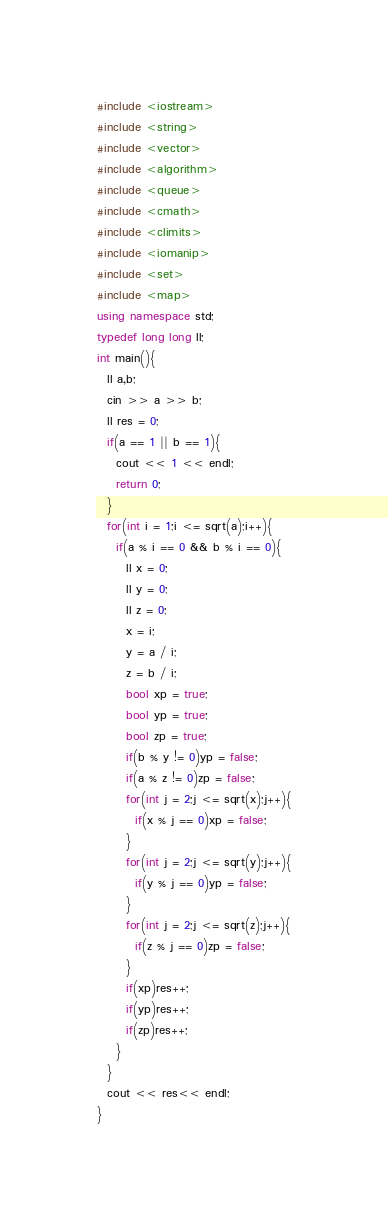Convert code to text. <code><loc_0><loc_0><loc_500><loc_500><_C++_>#include <iostream>
#include <string>
#include <vector>
#include <algorithm>
#include <queue>
#include <cmath>
#include <climits>
#include <iomanip>
#include <set>
#include <map>
using namespace std;
typedef long long ll;
int main(){
  ll a,b;
  cin >> a >> b;
  ll res = 0;
  if(a == 1 || b == 1){
    cout << 1 << endl;
    return 0;
  }
  for(int i = 1;i <= sqrt(a);i++){
    if(a % i == 0 && b % i == 0){
      ll x = 0;
      ll y = 0;
      ll z = 0;
      x = i;
      y = a / i;
      z = b / i;
      bool xp = true;
      bool yp = true;
      bool zp = true;
      if(b % y != 0)yp = false;
      if(a % z != 0)zp = false;
      for(int j = 2;j <= sqrt(x);j++){
        if(x % j == 0)xp = false;
      }
      for(int j = 2;j <= sqrt(y);j++){
        if(y % j == 0)yp = false;
      }
      for(int j = 2;j <= sqrt(z);j++){
        if(z % j == 0)zp = false;
      }
      if(xp)res++;
      if(yp)res++;
      if(zp)res++;
    }
  }
  cout << res<< endl;
}</code> 